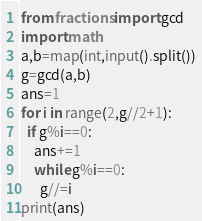Convert code to text. <code><loc_0><loc_0><loc_500><loc_500><_Python_>from fractions import gcd
import math
a,b=map(int,input().split())
g=gcd(a,b)
ans=1
for i in range(2,g//2+1):
  if g%i==0:
    ans+=1
    while g%i==0:
      g//=i
print(ans)</code> 